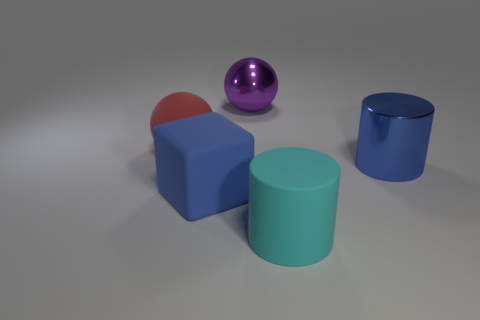Add 4 yellow metal objects. How many objects exist? 9 Subtract all cyan cylinders. How many cylinders are left? 1 Add 3 large shiny cylinders. How many large shiny cylinders exist? 4 Subtract 0 cyan blocks. How many objects are left? 5 Subtract all cubes. How many objects are left? 4 Subtract 1 blocks. How many blocks are left? 0 Subtract all red spheres. Subtract all blue cubes. How many spheres are left? 1 Subtract all gray balls. How many gray cylinders are left? 0 Subtract all large matte cylinders. Subtract all tiny red matte cubes. How many objects are left? 4 Add 3 big blue cylinders. How many big blue cylinders are left? 4 